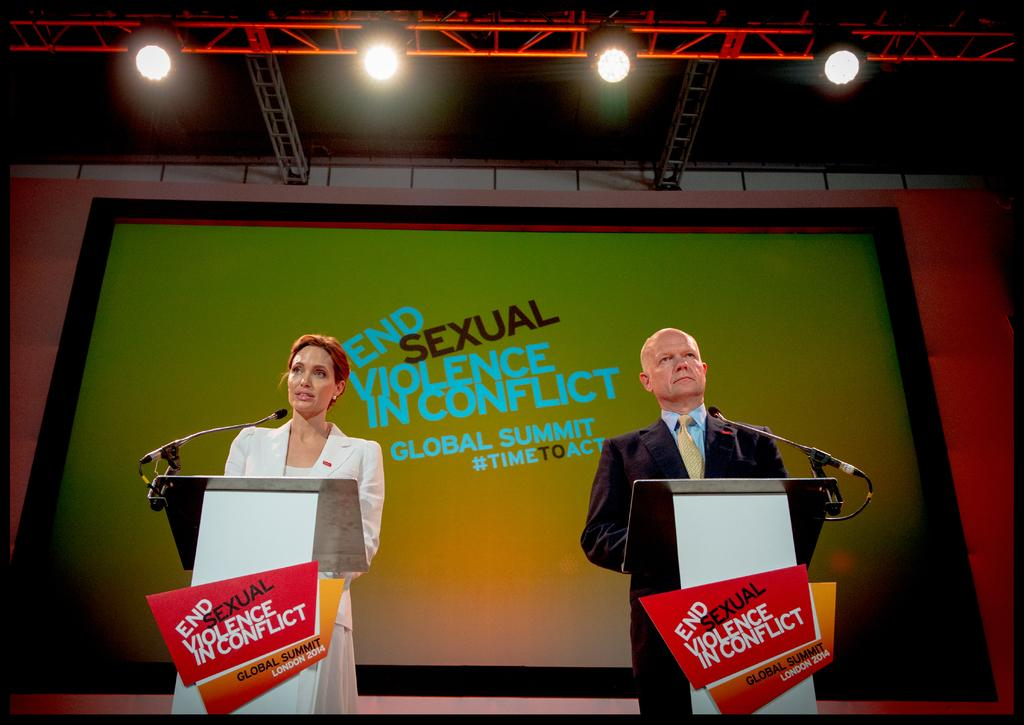How many people are standing in front of the dais in the image? There are two people standing in front of the dais in the image. What can be seen on top of the dais? There are microphones on top of the dais. What is located behind the people in the image? There is a screen behind the people. What type of lighting is visible in the image? There are lights visible at the top of the image. Can you tell me how many donkeys are present on the dais in the image? There are no donkeys present in the image; the dais has microphones on top of it. What type of flowers can be seen growing on the screen behind the people? There are no flowers visible on the screen behind the people; the screen is blank or displaying something else. 